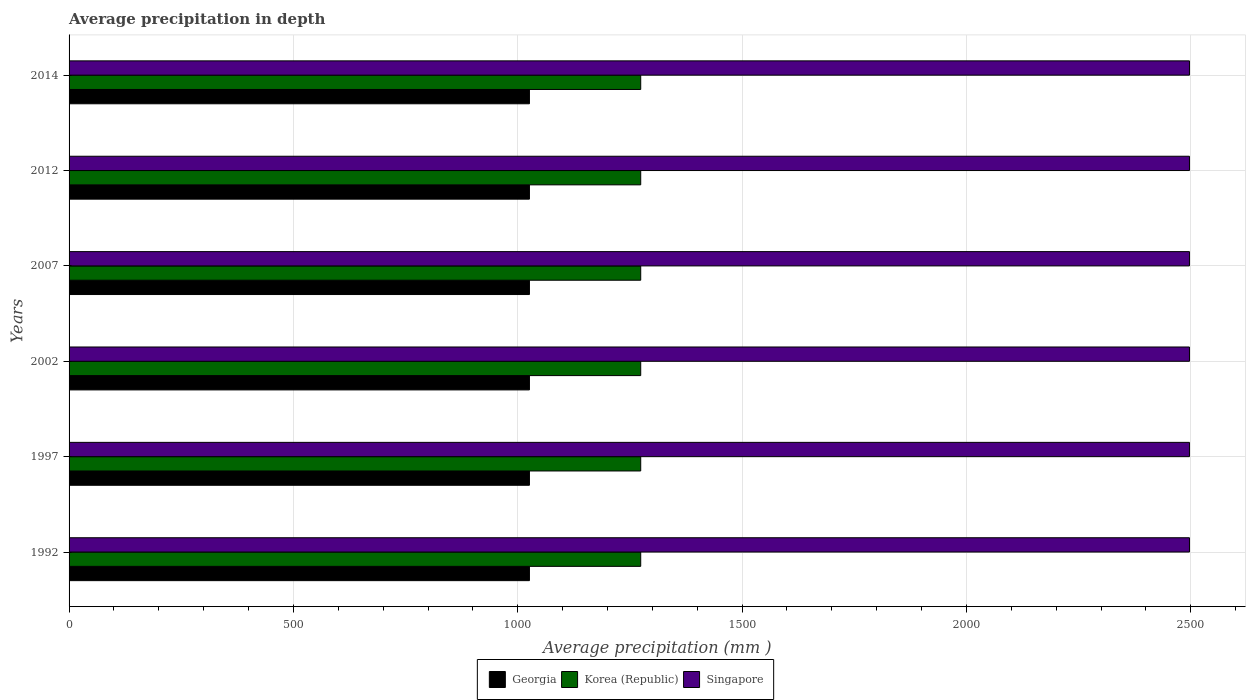How many different coloured bars are there?
Keep it short and to the point. 3. Are the number of bars on each tick of the Y-axis equal?
Offer a very short reply. Yes. What is the label of the 2nd group of bars from the top?
Offer a very short reply. 2012. In how many cases, is the number of bars for a given year not equal to the number of legend labels?
Your response must be concise. 0. What is the average precipitation in Singapore in 1992?
Offer a very short reply. 2497. Across all years, what is the maximum average precipitation in Singapore?
Provide a short and direct response. 2497. Across all years, what is the minimum average precipitation in Singapore?
Your answer should be very brief. 2497. In which year was the average precipitation in Georgia maximum?
Give a very brief answer. 1992. What is the total average precipitation in Georgia in the graph?
Offer a very short reply. 6156. What is the difference between the average precipitation in Georgia in 2002 and that in 2007?
Give a very brief answer. 0. What is the difference between the average precipitation in Singapore in 1992 and the average precipitation in Georgia in 2002?
Ensure brevity in your answer.  1471. What is the average average precipitation in Georgia per year?
Ensure brevity in your answer.  1026. In the year 1997, what is the difference between the average precipitation in Korea (Republic) and average precipitation in Singapore?
Provide a short and direct response. -1223. What is the difference between the highest and the second highest average precipitation in Singapore?
Provide a succinct answer. 0. What is the difference between the highest and the lowest average precipitation in Georgia?
Keep it short and to the point. 0. Is the sum of the average precipitation in Korea (Republic) in 1992 and 2007 greater than the maximum average precipitation in Singapore across all years?
Offer a very short reply. Yes. What does the 1st bar from the top in 1992 represents?
Ensure brevity in your answer.  Singapore. What does the 3rd bar from the bottom in 2012 represents?
Ensure brevity in your answer.  Singapore. How many bars are there?
Offer a very short reply. 18. What is the difference between two consecutive major ticks on the X-axis?
Provide a short and direct response. 500. Are the values on the major ticks of X-axis written in scientific E-notation?
Your answer should be compact. No. Does the graph contain any zero values?
Provide a short and direct response. No. How many legend labels are there?
Offer a terse response. 3. What is the title of the graph?
Make the answer very short. Average precipitation in depth. Does "Tuvalu" appear as one of the legend labels in the graph?
Offer a terse response. No. What is the label or title of the X-axis?
Offer a very short reply. Average precipitation (mm ). What is the Average precipitation (mm ) in Georgia in 1992?
Provide a succinct answer. 1026. What is the Average precipitation (mm ) in Korea (Republic) in 1992?
Keep it short and to the point. 1274. What is the Average precipitation (mm ) in Singapore in 1992?
Your response must be concise. 2497. What is the Average precipitation (mm ) of Georgia in 1997?
Offer a very short reply. 1026. What is the Average precipitation (mm ) of Korea (Republic) in 1997?
Ensure brevity in your answer.  1274. What is the Average precipitation (mm ) in Singapore in 1997?
Offer a terse response. 2497. What is the Average precipitation (mm ) in Georgia in 2002?
Your answer should be very brief. 1026. What is the Average precipitation (mm ) in Korea (Republic) in 2002?
Give a very brief answer. 1274. What is the Average precipitation (mm ) in Singapore in 2002?
Give a very brief answer. 2497. What is the Average precipitation (mm ) of Georgia in 2007?
Provide a short and direct response. 1026. What is the Average precipitation (mm ) of Korea (Republic) in 2007?
Your answer should be compact. 1274. What is the Average precipitation (mm ) in Singapore in 2007?
Your answer should be very brief. 2497. What is the Average precipitation (mm ) of Georgia in 2012?
Give a very brief answer. 1026. What is the Average precipitation (mm ) in Korea (Republic) in 2012?
Your answer should be very brief. 1274. What is the Average precipitation (mm ) in Singapore in 2012?
Offer a very short reply. 2497. What is the Average precipitation (mm ) of Georgia in 2014?
Ensure brevity in your answer.  1026. What is the Average precipitation (mm ) in Korea (Republic) in 2014?
Offer a terse response. 1274. What is the Average precipitation (mm ) in Singapore in 2014?
Your response must be concise. 2497. Across all years, what is the maximum Average precipitation (mm ) of Georgia?
Offer a terse response. 1026. Across all years, what is the maximum Average precipitation (mm ) of Korea (Republic)?
Provide a succinct answer. 1274. Across all years, what is the maximum Average precipitation (mm ) in Singapore?
Your answer should be compact. 2497. Across all years, what is the minimum Average precipitation (mm ) in Georgia?
Offer a terse response. 1026. Across all years, what is the minimum Average precipitation (mm ) of Korea (Republic)?
Make the answer very short. 1274. Across all years, what is the minimum Average precipitation (mm ) in Singapore?
Give a very brief answer. 2497. What is the total Average precipitation (mm ) in Georgia in the graph?
Your response must be concise. 6156. What is the total Average precipitation (mm ) of Korea (Republic) in the graph?
Ensure brevity in your answer.  7644. What is the total Average precipitation (mm ) of Singapore in the graph?
Offer a very short reply. 1.50e+04. What is the difference between the Average precipitation (mm ) in Korea (Republic) in 1992 and that in 1997?
Your response must be concise. 0. What is the difference between the Average precipitation (mm ) of Singapore in 1992 and that in 1997?
Make the answer very short. 0. What is the difference between the Average precipitation (mm ) of Georgia in 1992 and that in 2002?
Offer a very short reply. 0. What is the difference between the Average precipitation (mm ) in Korea (Republic) in 1992 and that in 2002?
Your answer should be compact. 0. What is the difference between the Average precipitation (mm ) of Georgia in 1992 and that in 2007?
Provide a short and direct response. 0. What is the difference between the Average precipitation (mm ) of Korea (Republic) in 1992 and that in 2007?
Provide a short and direct response. 0. What is the difference between the Average precipitation (mm ) of Korea (Republic) in 1992 and that in 2012?
Provide a short and direct response. 0. What is the difference between the Average precipitation (mm ) of Singapore in 1992 and that in 2012?
Your answer should be compact. 0. What is the difference between the Average precipitation (mm ) in Georgia in 1992 and that in 2014?
Make the answer very short. 0. What is the difference between the Average precipitation (mm ) in Korea (Republic) in 1992 and that in 2014?
Your answer should be compact. 0. What is the difference between the Average precipitation (mm ) in Singapore in 1992 and that in 2014?
Make the answer very short. 0. What is the difference between the Average precipitation (mm ) in Georgia in 1997 and that in 2002?
Provide a short and direct response. 0. What is the difference between the Average precipitation (mm ) in Korea (Republic) in 1997 and that in 2002?
Your answer should be very brief. 0. What is the difference between the Average precipitation (mm ) in Singapore in 1997 and that in 2002?
Make the answer very short. 0. What is the difference between the Average precipitation (mm ) in Georgia in 1997 and that in 2007?
Make the answer very short. 0. What is the difference between the Average precipitation (mm ) of Korea (Republic) in 1997 and that in 2007?
Your answer should be compact. 0. What is the difference between the Average precipitation (mm ) in Singapore in 1997 and that in 2007?
Provide a succinct answer. 0. What is the difference between the Average precipitation (mm ) of Korea (Republic) in 1997 and that in 2014?
Your response must be concise. 0. What is the difference between the Average precipitation (mm ) of Georgia in 2002 and that in 2007?
Give a very brief answer. 0. What is the difference between the Average precipitation (mm ) in Singapore in 2002 and that in 2007?
Your response must be concise. 0. What is the difference between the Average precipitation (mm ) in Georgia in 2002 and that in 2012?
Give a very brief answer. 0. What is the difference between the Average precipitation (mm ) in Korea (Republic) in 2002 and that in 2012?
Provide a short and direct response. 0. What is the difference between the Average precipitation (mm ) in Georgia in 2002 and that in 2014?
Your answer should be compact. 0. What is the difference between the Average precipitation (mm ) of Singapore in 2002 and that in 2014?
Offer a terse response. 0. What is the difference between the Average precipitation (mm ) in Singapore in 2007 and that in 2014?
Offer a terse response. 0. What is the difference between the Average precipitation (mm ) of Georgia in 2012 and that in 2014?
Keep it short and to the point. 0. What is the difference between the Average precipitation (mm ) in Korea (Republic) in 2012 and that in 2014?
Keep it short and to the point. 0. What is the difference between the Average precipitation (mm ) in Georgia in 1992 and the Average precipitation (mm ) in Korea (Republic) in 1997?
Offer a terse response. -248. What is the difference between the Average precipitation (mm ) in Georgia in 1992 and the Average precipitation (mm ) in Singapore in 1997?
Offer a terse response. -1471. What is the difference between the Average precipitation (mm ) of Korea (Republic) in 1992 and the Average precipitation (mm ) of Singapore in 1997?
Make the answer very short. -1223. What is the difference between the Average precipitation (mm ) in Georgia in 1992 and the Average precipitation (mm ) in Korea (Republic) in 2002?
Your response must be concise. -248. What is the difference between the Average precipitation (mm ) in Georgia in 1992 and the Average precipitation (mm ) in Singapore in 2002?
Provide a short and direct response. -1471. What is the difference between the Average precipitation (mm ) of Korea (Republic) in 1992 and the Average precipitation (mm ) of Singapore in 2002?
Your answer should be very brief. -1223. What is the difference between the Average precipitation (mm ) in Georgia in 1992 and the Average precipitation (mm ) in Korea (Republic) in 2007?
Provide a short and direct response. -248. What is the difference between the Average precipitation (mm ) in Georgia in 1992 and the Average precipitation (mm ) in Singapore in 2007?
Make the answer very short. -1471. What is the difference between the Average precipitation (mm ) in Korea (Republic) in 1992 and the Average precipitation (mm ) in Singapore in 2007?
Your answer should be compact. -1223. What is the difference between the Average precipitation (mm ) in Georgia in 1992 and the Average precipitation (mm ) in Korea (Republic) in 2012?
Provide a short and direct response. -248. What is the difference between the Average precipitation (mm ) of Georgia in 1992 and the Average precipitation (mm ) of Singapore in 2012?
Your response must be concise. -1471. What is the difference between the Average precipitation (mm ) in Korea (Republic) in 1992 and the Average precipitation (mm ) in Singapore in 2012?
Make the answer very short. -1223. What is the difference between the Average precipitation (mm ) of Georgia in 1992 and the Average precipitation (mm ) of Korea (Republic) in 2014?
Provide a succinct answer. -248. What is the difference between the Average precipitation (mm ) of Georgia in 1992 and the Average precipitation (mm ) of Singapore in 2014?
Your answer should be compact. -1471. What is the difference between the Average precipitation (mm ) of Korea (Republic) in 1992 and the Average precipitation (mm ) of Singapore in 2014?
Offer a terse response. -1223. What is the difference between the Average precipitation (mm ) of Georgia in 1997 and the Average precipitation (mm ) of Korea (Republic) in 2002?
Make the answer very short. -248. What is the difference between the Average precipitation (mm ) of Georgia in 1997 and the Average precipitation (mm ) of Singapore in 2002?
Keep it short and to the point. -1471. What is the difference between the Average precipitation (mm ) of Korea (Republic) in 1997 and the Average precipitation (mm ) of Singapore in 2002?
Give a very brief answer. -1223. What is the difference between the Average precipitation (mm ) of Georgia in 1997 and the Average precipitation (mm ) of Korea (Republic) in 2007?
Offer a very short reply. -248. What is the difference between the Average precipitation (mm ) in Georgia in 1997 and the Average precipitation (mm ) in Singapore in 2007?
Keep it short and to the point. -1471. What is the difference between the Average precipitation (mm ) of Korea (Republic) in 1997 and the Average precipitation (mm ) of Singapore in 2007?
Your response must be concise. -1223. What is the difference between the Average precipitation (mm ) of Georgia in 1997 and the Average precipitation (mm ) of Korea (Republic) in 2012?
Offer a very short reply. -248. What is the difference between the Average precipitation (mm ) of Georgia in 1997 and the Average precipitation (mm ) of Singapore in 2012?
Offer a very short reply. -1471. What is the difference between the Average precipitation (mm ) of Korea (Republic) in 1997 and the Average precipitation (mm ) of Singapore in 2012?
Your response must be concise. -1223. What is the difference between the Average precipitation (mm ) in Georgia in 1997 and the Average precipitation (mm ) in Korea (Republic) in 2014?
Your answer should be very brief. -248. What is the difference between the Average precipitation (mm ) in Georgia in 1997 and the Average precipitation (mm ) in Singapore in 2014?
Your response must be concise. -1471. What is the difference between the Average precipitation (mm ) in Korea (Republic) in 1997 and the Average precipitation (mm ) in Singapore in 2014?
Your answer should be very brief. -1223. What is the difference between the Average precipitation (mm ) of Georgia in 2002 and the Average precipitation (mm ) of Korea (Republic) in 2007?
Offer a very short reply. -248. What is the difference between the Average precipitation (mm ) in Georgia in 2002 and the Average precipitation (mm ) in Singapore in 2007?
Provide a succinct answer. -1471. What is the difference between the Average precipitation (mm ) of Korea (Republic) in 2002 and the Average precipitation (mm ) of Singapore in 2007?
Ensure brevity in your answer.  -1223. What is the difference between the Average precipitation (mm ) of Georgia in 2002 and the Average precipitation (mm ) of Korea (Republic) in 2012?
Offer a terse response. -248. What is the difference between the Average precipitation (mm ) in Georgia in 2002 and the Average precipitation (mm ) in Singapore in 2012?
Offer a very short reply. -1471. What is the difference between the Average precipitation (mm ) in Korea (Republic) in 2002 and the Average precipitation (mm ) in Singapore in 2012?
Give a very brief answer. -1223. What is the difference between the Average precipitation (mm ) in Georgia in 2002 and the Average precipitation (mm ) in Korea (Republic) in 2014?
Your answer should be very brief. -248. What is the difference between the Average precipitation (mm ) in Georgia in 2002 and the Average precipitation (mm ) in Singapore in 2014?
Offer a terse response. -1471. What is the difference between the Average precipitation (mm ) in Korea (Republic) in 2002 and the Average precipitation (mm ) in Singapore in 2014?
Your response must be concise. -1223. What is the difference between the Average precipitation (mm ) of Georgia in 2007 and the Average precipitation (mm ) of Korea (Republic) in 2012?
Provide a succinct answer. -248. What is the difference between the Average precipitation (mm ) of Georgia in 2007 and the Average precipitation (mm ) of Singapore in 2012?
Offer a very short reply. -1471. What is the difference between the Average precipitation (mm ) in Korea (Republic) in 2007 and the Average precipitation (mm ) in Singapore in 2012?
Make the answer very short. -1223. What is the difference between the Average precipitation (mm ) in Georgia in 2007 and the Average precipitation (mm ) in Korea (Republic) in 2014?
Your answer should be very brief. -248. What is the difference between the Average precipitation (mm ) of Georgia in 2007 and the Average precipitation (mm ) of Singapore in 2014?
Your response must be concise. -1471. What is the difference between the Average precipitation (mm ) in Korea (Republic) in 2007 and the Average precipitation (mm ) in Singapore in 2014?
Give a very brief answer. -1223. What is the difference between the Average precipitation (mm ) of Georgia in 2012 and the Average precipitation (mm ) of Korea (Republic) in 2014?
Provide a succinct answer. -248. What is the difference between the Average precipitation (mm ) of Georgia in 2012 and the Average precipitation (mm ) of Singapore in 2014?
Keep it short and to the point. -1471. What is the difference between the Average precipitation (mm ) of Korea (Republic) in 2012 and the Average precipitation (mm ) of Singapore in 2014?
Your answer should be very brief. -1223. What is the average Average precipitation (mm ) of Georgia per year?
Make the answer very short. 1026. What is the average Average precipitation (mm ) in Korea (Republic) per year?
Offer a terse response. 1274. What is the average Average precipitation (mm ) of Singapore per year?
Give a very brief answer. 2497. In the year 1992, what is the difference between the Average precipitation (mm ) in Georgia and Average precipitation (mm ) in Korea (Republic)?
Ensure brevity in your answer.  -248. In the year 1992, what is the difference between the Average precipitation (mm ) of Georgia and Average precipitation (mm ) of Singapore?
Ensure brevity in your answer.  -1471. In the year 1992, what is the difference between the Average precipitation (mm ) in Korea (Republic) and Average precipitation (mm ) in Singapore?
Ensure brevity in your answer.  -1223. In the year 1997, what is the difference between the Average precipitation (mm ) in Georgia and Average precipitation (mm ) in Korea (Republic)?
Offer a very short reply. -248. In the year 1997, what is the difference between the Average precipitation (mm ) of Georgia and Average precipitation (mm ) of Singapore?
Offer a terse response. -1471. In the year 1997, what is the difference between the Average precipitation (mm ) of Korea (Republic) and Average precipitation (mm ) of Singapore?
Ensure brevity in your answer.  -1223. In the year 2002, what is the difference between the Average precipitation (mm ) in Georgia and Average precipitation (mm ) in Korea (Republic)?
Offer a terse response. -248. In the year 2002, what is the difference between the Average precipitation (mm ) of Georgia and Average precipitation (mm ) of Singapore?
Keep it short and to the point. -1471. In the year 2002, what is the difference between the Average precipitation (mm ) in Korea (Republic) and Average precipitation (mm ) in Singapore?
Offer a very short reply. -1223. In the year 2007, what is the difference between the Average precipitation (mm ) in Georgia and Average precipitation (mm ) in Korea (Republic)?
Keep it short and to the point. -248. In the year 2007, what is the difference between the Average precipitation (mm ) of Georgia and Average precipitation (mm ) of Singapore?
Offer a terse response. -1471. In the year 2007, what is the difference between the Average precipitation (mm ) in Korea (Republic) and Average precipitation (mm ) in Singapore?
Your answer should be compact. -1223. In the year 2012, what is the difference between the Average precipitation (mm ) in Georgia and Average precipitation (mm ) in Korea (Republic)?
Your response must be concise. -248. In the year 2012, what is the difference between the Average precipitation (mm ) in Georgia and Average precipitation (mm ) in Singapore?
Ensure brevity in your answer.  -1471. In the year 2012, what is the difference between the Average precipitation (mm ) of Korea (Republic) and Average precipitation (mm ) of Singapore?
Your answer should be very brief. -1223. In the year 2014, what is the difference between the Average precipitation (mm ) in Georgia and Average precipitation (mm ) in Korea (Republic)?
Your answer should be very brief. -248. In the year 2014, what is the difference between the Average precipitation (mm ) in Georgia and Average precipitation (mm ) in Singapore?
Your answer should be compact. -1471. In the year 2014, what is the difference between the Average precipitation (mm ) of Korea (Republic) and Average precipitation (mm ) of Singapore?
Offer a very short reply. -1223. What is the ratio of the Average precipitation (mm ) in Korea (Republic) in 1992 to that in 1997?
Offer a terse response. 1. What is the ratio of the Average precipitation (mm ) of Singapore in 1992 to that in 1997?
Make the answer very short. 1. What is the ratio of the Average precipitation (mm ) in Georgia in 1992 to that in 2002?
Provide a short and direct response. 1. What is the ratio of the Average precipitation (mm ) of Korea (Republic) in 1992 to that in 2002?
Ensure brevity in your answer.  1. What is the ratio of the Average precipitation (mm ) in Singapore in 1992 to that in 2002?
Your answer should be compact. 1. What is the ratio of the Average precipitation (mm ) of Georgia in 1992 to that in 2007?
Provide a succinct answer. 1. What is the ratio of the Average precipitation (mm ) of Singapore in 1992 to that in 2007?
Offer a terse response. 1. What is the ratio of the Average precipitation (mm ) in Korea (Republic) in 1992 to that in 2012?
Provide a succinct answer. 1. What is the ratio of the Average precipitation (mm ) of Singapore in 1992 to that in 2012?
Offer a very short reply. 1. What is the ratio of the Average precipitation (mm ) in Korea (Republic) in 1992 to that in 2014?
Your answer should be compact. 1. What is the ratio of the Average precipitation (mm ) in Georgia in 1997 to that in 2002?
Keep it short and to the point. 1. What is the ratio of the Average precipitation (mm ) of Singapore in 1997 to that in 2002?
Offer a very short reply. 1. What is the ratio of the Average precipitation (mm ) of Korea (Republic) in 1997 to that in 2007?
Your answer should be compact. 1. What is the ratio of the Average precipitation (mm ) of Georgia in 2002 to that in 2007?
Provide a short and direct response. 1. What is the ratio of the Average precipitation (mm ) of Singapore in 2002 to that in 2007?
Ensure brevity in your answer.  1. What is the ratio of the Average precipitation (mm ) in Georgia in 2002 to that in 2012?
Offer a very short reply. 1. What is the ratio of the Average precipitation (mm ) in Georgia in 2002 to that in 2014?
Offer a very short reply. 1. What is the ratio of the Average precipitation (mm ) in Singapore in 2002 to that in 2014?
Your response must be concise. 1. What is the ratio of the Average precipitation (mm ) in Georgia in 2007 to that in 2012?
Give a very brief answer. 1. What is the ratio of the Average precipitation (mm ) in Georgia in 2007 to that in 2014?
Provide a short and direct response. 1. What is the ratio of the Average precipitation (mm ) of Singapore in 2007 to that in 2014?
Provide a short and direct response. 1. What is the ratio of the Average precipitation (mm ) in Singapore in 2012 to that in 2014?
Your answer should be very brief. 1. What is the difference between the highest and the lowest Average precipitation (mm ) in Georgia?
Keep it short and to the point. 0. What is the difference between the highest and the lowest Average precipitation (mm ) of Korea (Republic)?
Provide a succinct answer. 0. 